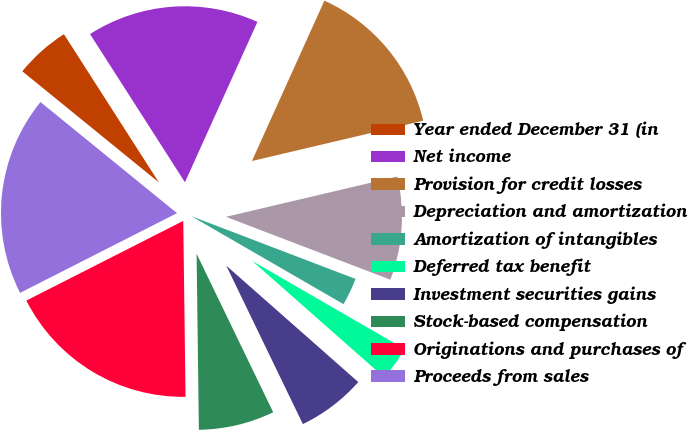Convert chart. <chart><loc_0><loc_0><loc_500><loc_500><pie_chart><fcel>Year ended December 31 (in<fcel>Net income<fcel>Provision for credit losses<fcel>Depreciation and amortization<fcel>Amortization of intangibles<fcel>Deferred tax benefit<fcel>Investment securities gains<fcel>Stock-based compensation<fcel>Originations and purchases of<fcel>Proceeds from sales<nl><fcel>5.06%<fcel>15.82%<fcel>14.56%<fcel>9.49%<fcel>2.53%<fcel>3.16%<fcel>6.33%<fcel>6.96%<fcel>17.72%<fcel>18.35%<nl></chart> 